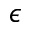<formula> <loc_0><loc_0><loc_500><loc_500>\epsilon</formula> 